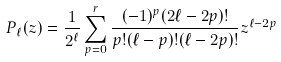<formula> <loc_0><loc_0><loc_500><loc_500>P _ { \ell } ( z ) = \frac { 1 } { 2 ^ { \ell } } \sum _ { p = 0 } ^ { r } \frac { ( - 1 ) ^ { p } ( 2 \ell - 2 p ) ! } { p ! ( \ell - p ) ! ( \ell - 2 p ) ! } z ^ { \ell - 2 p }</formula> 